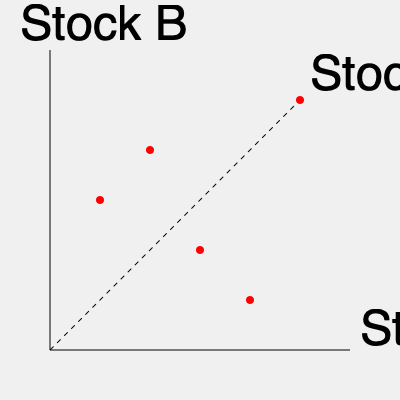Based on the 3D scatter plot showing the relationship between Stocks A, B, and C, what can be inferred about the correlation between Stock A and Stock B? To interpret the correlation between Stock A and Stock B from this 3D scatter plot, we need to follow these steps:

1. Understand the axes: 
   - The x-axis represents Stock A
   - The y-axis represents Stock B
   - The z-axis (coming out of the page) represents Stock C

2. Ignore the Stock C dimension:
   Since we're only interested in the correlation between Stocks A and B, we need to focus on the projection of the points onto the x-y plane.

3. Analyze the pattern:
   Looking at the projection of the points onto the x-y plane (ignoring their position along the Stock C axis), we can see a clear pattern.

4. Interpret the pattern:
   The points form a line that moves from the bottom-left to the top-right of the x-y plane. This indicates a positive correlation.

5. Assess the strength:
   The points appear to form a fairly straight line with little scatter, suggesting a strong positive correlation.

6. Mathematical interpretation:
   In terms of the correlation coefficient $r$, this pattern suggests a value close to 1, indicating a strong positive correlation.

Therefore, based on this 3D scatter plot, we can infer that there is a strong positive correlation between Stock A and Stock B.
Answer: Strong positive correlation 